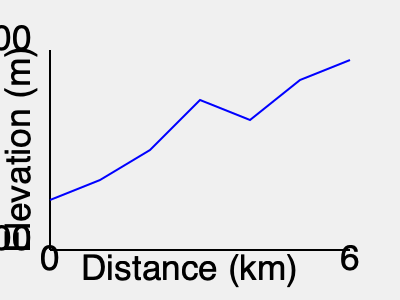As an experienced traveler, you're planning to share this topographic map of a popular hiking trail with your community. What is the approximate total elevation gain from the start to the end of this 6 km trail? To calculate the total elevation gain, we need to follow these steps:

1. Identify the starting elevation: The trail begins at approximately 800 meters (4/5 of the way up the y-axis from 500m to 1500m).

2. Identify the ending elevation: The trail ends at approximately 1400 meters (4/5 of the way up from 1000m to 1500m).

3. Calculate the difference:
   $1400 \text{ m} - 800 \text{ m} = 600 \text{ m}$

4. Account for elevation changes along the trail:
   - There's a significant dip around the 4 km mark, dropping to about 1100 meters.
   - The trail then climbs back up to 1400 meters.
   - This additional climb adds approximately 300 meters to the total elevation gain.

5. Sum up the total elevation gain:
   $600 \text{ m} + 300 \text{ m} = 900 \text{ m}$

Therefore, the approximate total elevation gain from start to finish is 900 meters.
Answer: 900 meters 